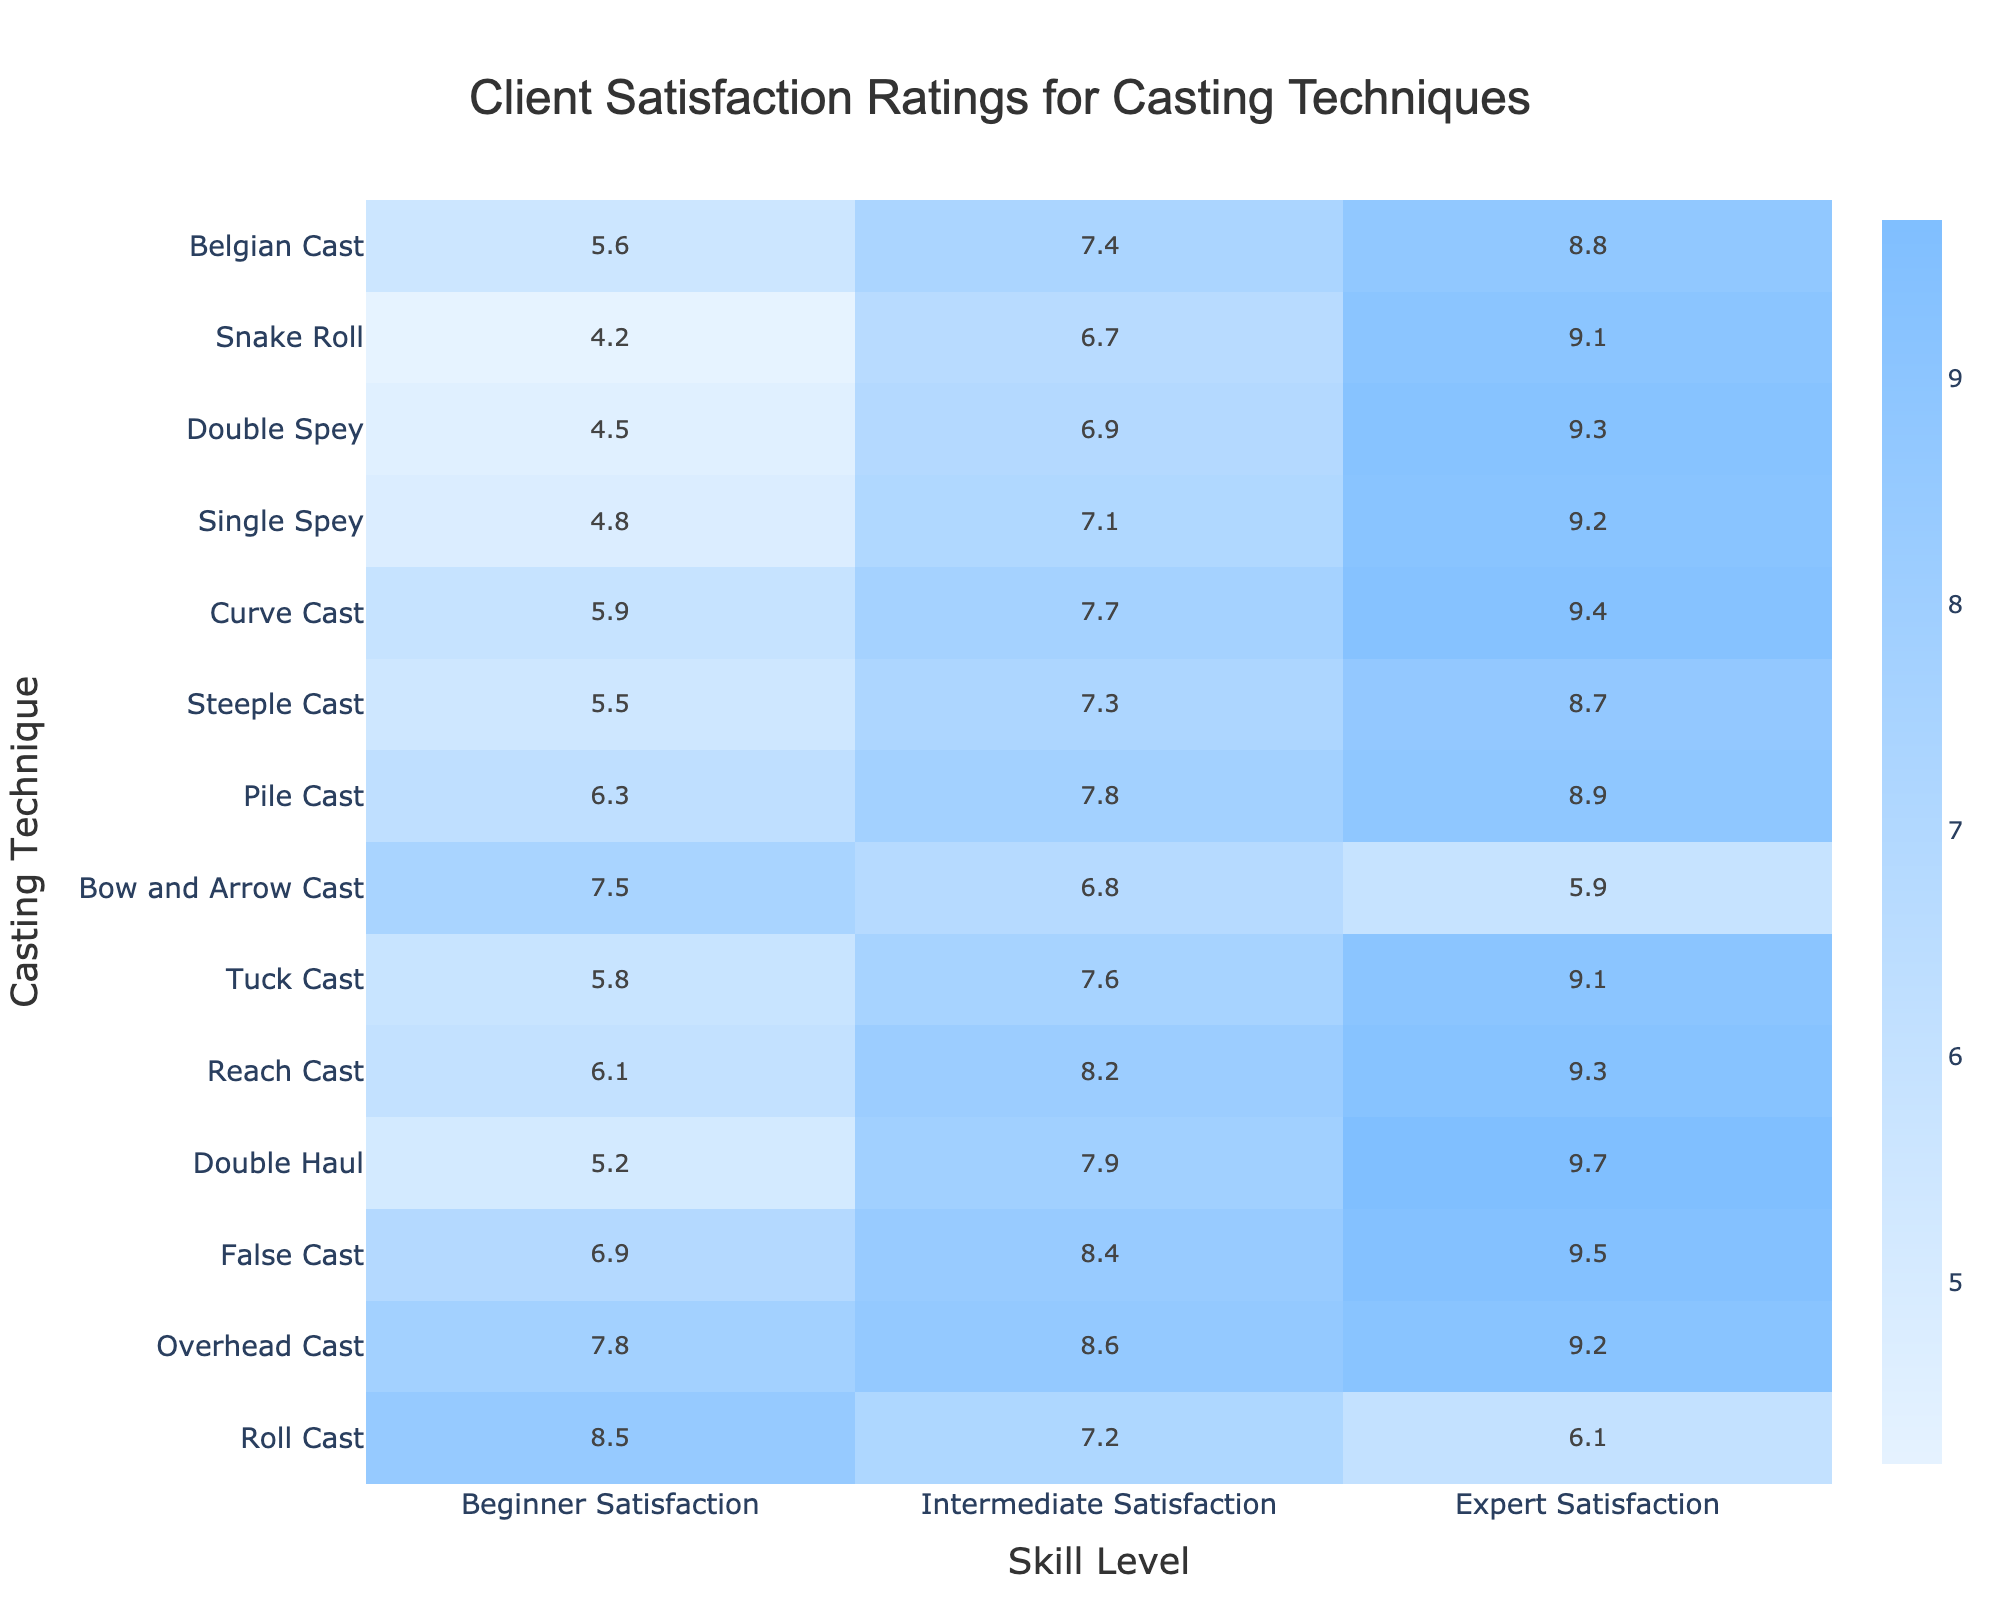What is the highest satisfaction rating for the Overhead Cast technique? Referring to the table, the Overhead Cast has satisfaction ratings of 7.8 for Beginners, 8.6 for Intermediates, and 9.2 for Experts. The highest rating among these is 9.2 for Experts.
Answer: 9.2 Which casting technique has the lowest beginner satisfaction rating? Looking at the table, the lowest beginner satisfaction rating is found in the Single Spey technique, which has a rating of 4.8.
Answer: 4.8 What is the average satisfaction rating for the Double Haul technique? The ratings for the Double Haul are 5.2 for Beginners, 7.9 for Intermediates, and 9.7 for Experts. Adding these ratings gives us 5.2 + 7.9 + 9.7 = 22.8, and dividing by 3 yields an average of 22.8 / 3 = 7.6.
Answer: 7.6 Which technique has the highest satisfaction rating in the Intermediate category? The Intermediate ratings show that the highest value is 8.6 for the Overhead Cast.
Answer: Overhead Cast Is the gap in satisfaction ratings between the Beginner and Expert levels for False Cast greater than 2 points? The Beginner satisfaction for False Cast is 6.9 and the Expert satisfaction is 9.5, which gives a difference of 9.5 - 6.9 = 2.6. Since 2.6 is greater than 2, the answer is yes.
Answer: Yes For which casting technique is the difference between the Expert and Beginner ratings the smallest? To find this, we compare the differences between Expert and Beginner ratings for all techniques. The smallest difference is for the Bow and Arrow Cast, with ratings of 7.5 for Beginners and 5.9 for Experts, giving a difference of 7.5 - 5.9 = 1.6.
Answer: Bow and Arrow Cast What is the average satisfaction rating across all skill levels for the Roll Cast technique? The ratings for the Roll Cast are 8.5 for Beginners, 7.2 for Intermediates, and 6.1 for Experts. To find the average, we sum these values: 8.5 + 7.2 + 6.1 = 21.8, then divide by 3, resulting in an average of 21.8 / 3 = 7.27.
Answer: 7.27 Is the double haul technique more satisfying than the reach cast for intermediates? The Intermediate satisfaction rating for the Double Haul is 7.9, whereas for the Reach Cast, it is 8.2. Since 7.9 is less than 8.2, the Double Haul is not more satisfying.
Answer: No Which two techniques have the same Intermediate satisfaction rating? Upon examination, the Curve Cast and the Pile Cast each have an Intermediate satisfaction rating of 7.7 and 7.8, respectively. Thus, they are not the same, however, only comparing numbers recognizes that no techniques share exactly the same ratings in the said category.
Answer: None 